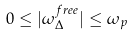Convert formula to latex. <formula><loc_0><loc_0><loc_500><loc_500>0 \leq | \omega _ { \Delta } ^ { f r e e } | \leq \omega _ { p }</formula> 